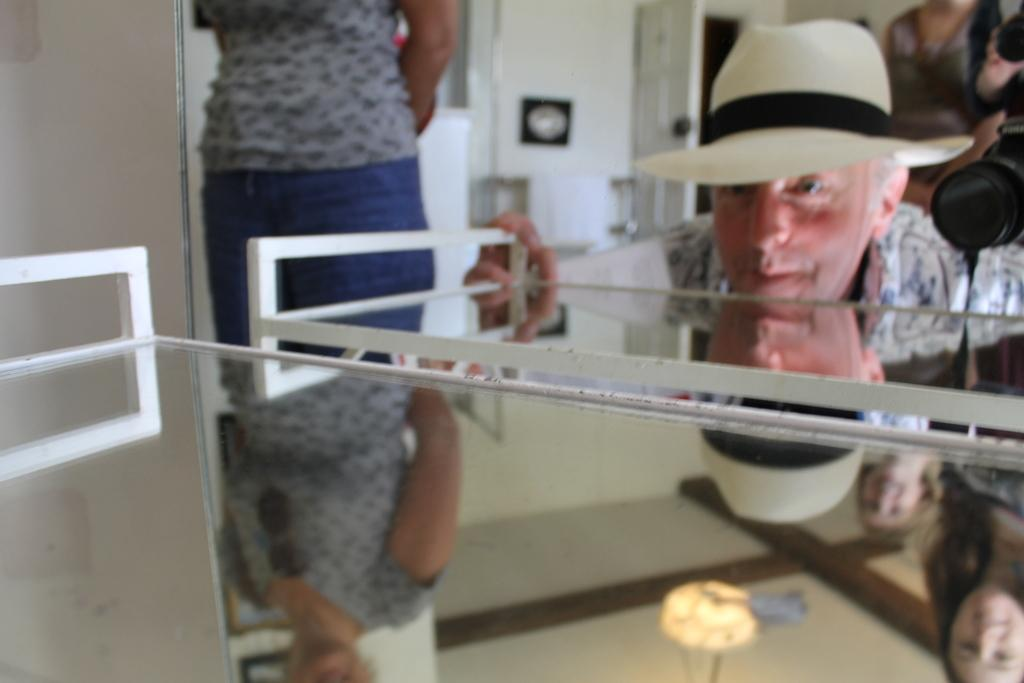What object in the image is typically used for drinking? There is a glass in the image, which is typically used for drinking. What object in the image is typically used for capturing images? There is a camera in the image, which is typically used for capturing images. How many people are present in the image? There are three people in the image. What architectural feature can be seen in the image? There is a door in the image. What structural element can be seen in the image? There is a wall in the image. What type of beam is being used by the people in the image? There is no beam present in the image; it features a glass, a camera, three people, a door, a wall, and some unspecified objects. What type of crayon can be seen in the image? There is no crayon present in the image. 